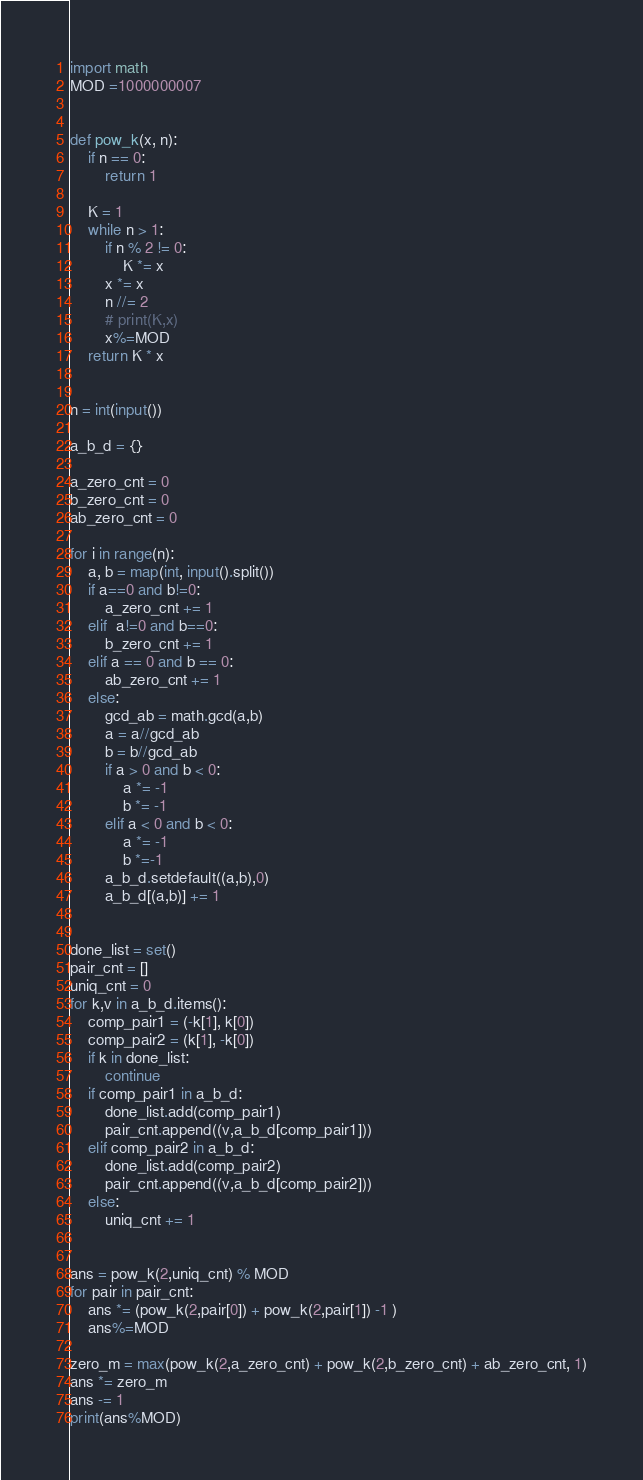<code> <loc_0><loc_0><loc_500><loc_500><_Python_>import math
MOD =1000000007


def pow_k(x, n):
    if n == 0:
        return 1

    K = 1
    while n > 1:
        if n % 2 != 0:
            K *= x
        x *= x
        n //= 2
        # print(K,x)
        x%=MOD
    return K * x


n = int(input())

a_b_d = {}

a_zero_cnt = 0
b_zero_cnt = 0
ab_zero_cnt = 0

for i in range(n):
    a, b = map(int, input().split()) 
    if a==0 and b!=0:
        a_zero_cnt += 1
    elif  a!=0 and b==0:
        b_zero_cnt += 1
    elif a == 0 and b == 0:
        ab_zero_cnt += 1
    else:
        gcd_ab = math.gcd(a,b)
        a = a//gcd_ab
        b = b//gcd_ab
        if a > 0 and b < 0:
            a *= -1
            b *= -1
        elif a < 0 and b < 0:
            a *= -1
            b *=-1
        a_b_d.setdefault((a,b),0)
        a_b_d[(a,b)] += 1


done_list = set()
pair_cnt = []
uniq_cnt = 0
for k,v in a_b_d.items():
    comp_pair1 = (-k[1], k[0])
    comp_pair2 = (k[1], -k[0])
    if k in done_list:
        continue
    if comp_pair1 in a_b_d:
        done_list.add(comp_pair1)
        pair_cnt.append((v,a_b_d[comp_pair1]))
    elif comp_pair2 in a_b_d:
        done_list.add(comp_pair2)
        pair_cnt.append((v,a_b_d[comp_pair2]))
    else:
        uniq_cnt += 1


ans = pow_k(2,uniq_cnt) % MOD
for pair in pair_cnt:
    ans *= (pow_k(2,pair[0]) + pow_k(2,pair[1]) -1 )
    ans%=MOD

zero_m = max(pow_k(2,a_zero_cnt) + pow_k(2,b_zero_cnt) + ab_zero_cnt, 1)
ans *= zero_m
ans -= 1
print(ans%MOD)</code> 